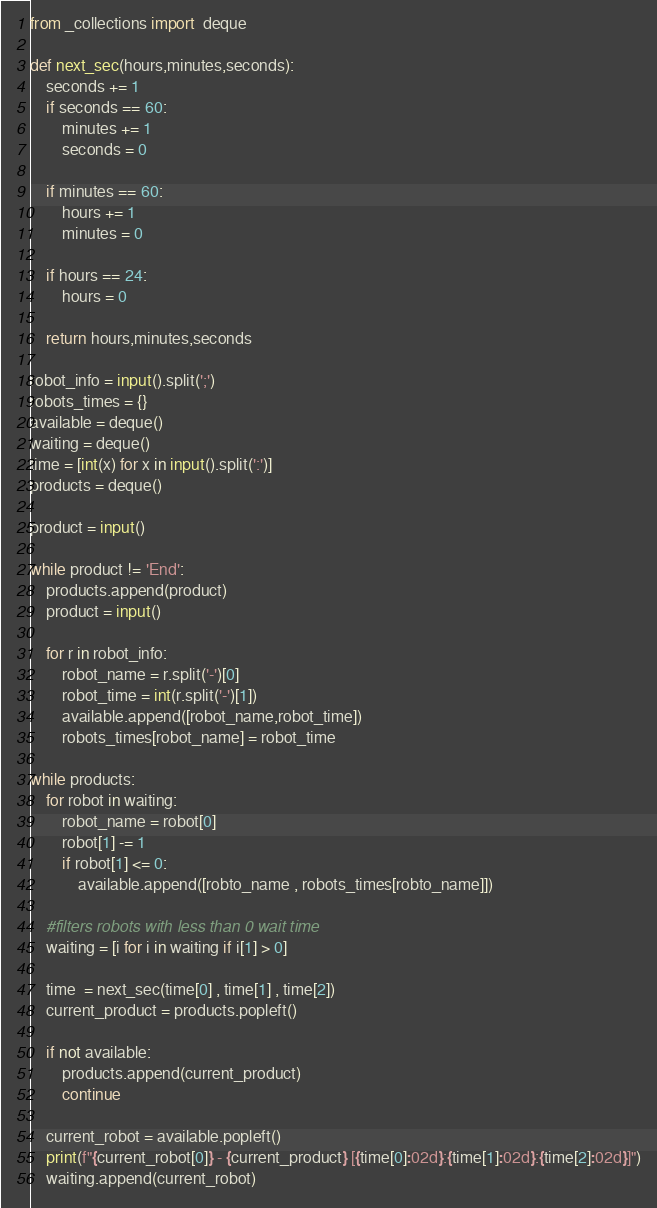Convert code to text. <code><loc_0><loc_0><loc_500><loc_500><_Python_>from _collections import  deque

def next_sec(hours,minutes,seconds):
    seconds += 1
    if seconds == 60:
        minutes += 1
        seconds = 0

    if minutes == 60:
        hours += 1
        minutes = 0

    if hours == 24:
        hours = 0

    return hours,minutes,seconds

robot_info = input().split(';')
robots_times = {}
available = deque()
waiting = deque()
time = [int(x) for x in input().split(':')]
products = deque()

product = input()

while product != 'End':
    products.append(product)
    product = input()

    for r in robot_info:
        robot_name = r.split('-')[0]
        robot_time = int(r.split('-')[1])
        available.append([robot_name,robot_time])
        robots_times[robot_name] = robot_time

while products:
    for robot in waiting:
        robot_name = robot[0]
        robot[1] -= 1
        if robot[1] <= 0:
            available.append([robto_name , robots_times[robto_name]])

    #filters robots with less than 0 wait time
    waiting = [i for i in waiting if i[1] > 0]

    time  = next_sec(time[0] , time[1] , time[2])
    current_product = products.popleft()

    if not available:
        products.append(current_product)
        continue

    current_robot = available.popleft()
    print(f"{current_robot[0]} - {current_product} [{time[0]:02d}:{time[1]:02d}:{time[2]:02d}]")
    waiting.append(current_robot)</code> 